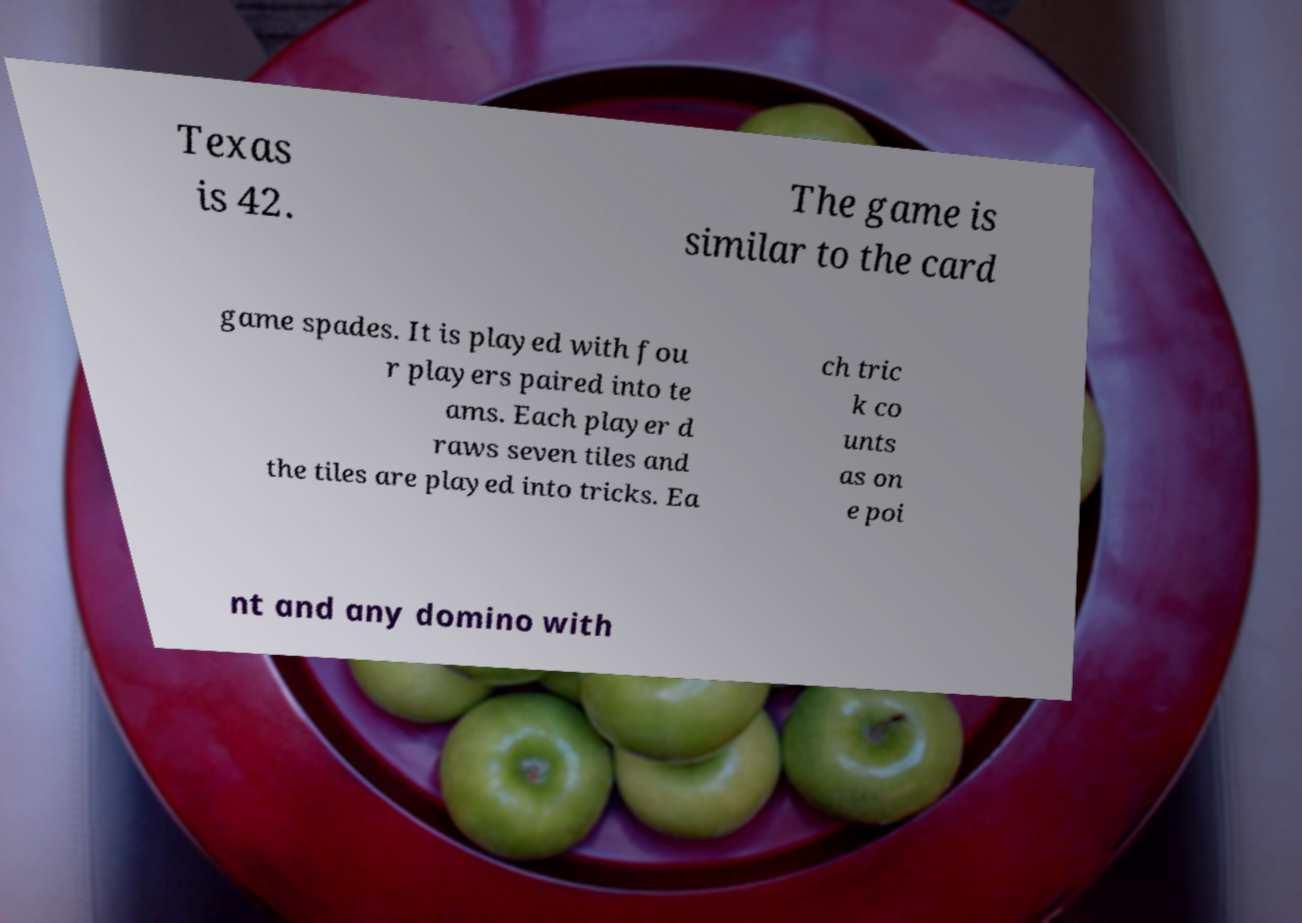Please identify and transcribe the text found in this image. Texas is 42. The game is similar to the card game spades. It is played with fou r players paired into te ams. Each player d raws seven tiles and the tiles are played into tricks. Ea ch tric k co unts as on e poi nt and any domino with 